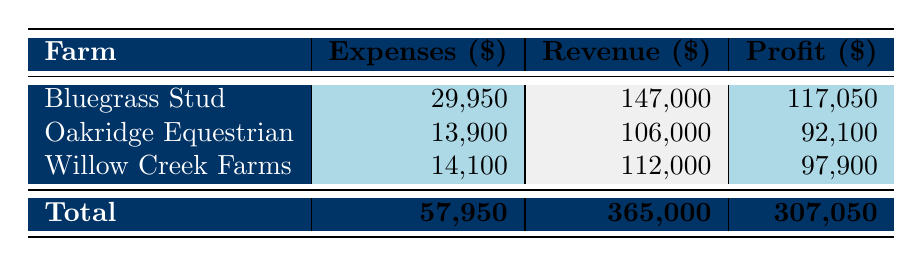What is the total profit for Bluegrass Stud? The profit for Bluegrass Stud can be found under the Profit column. It is stated as 117,050.
Answer: 117,050 How much did Willow Creek Farms spend on expenses? To find the total expenses for Willow Creek Farms, we refer to the Expenses column, which shows 14,100.
Answer: 14,100 Which farm has the highest revenue? The revenue amounts are 147,000 for Bluegrass Stud, 106,000 for Oakridge Equestrian, and 112,000 for Willow Creek Farms. Comparing these, Bluegrass Stud has the highest revenue.
Answer: Bluegrass Stud What is the total revenue across all farms? To find the total revenue, we sum the revenue for all farms: 147,000 + 106,000 + 112,000 = 365,000.
Answer: 365,000 Is the profit for Oakridge Equestrian greater than 80,000? The profit for Oakridge Equestrian is 92,100, which is more than 80,000.
Answer: Yes What is the average expense of the three farms? To calculate the average expenses, we first sum the total expenses: 29,950 + 13,900 + 14,100 = 57,950. Then we divide this by the number of farms, which is 3. Thus, the average is 57,950 / 3 = 19,316.67.
Answer: 19,316.67 Which farm has the lowest profit? The profits are 117,050 for Bluegrass Stud, 92,100 for Oakridge Equestrian, and 97,900 for Willow Creek Farms. Comparing these, Oakridge Equestrian has the lowest profit.
Answer: Oakridge Equestrian What is the difference in profit between Bluegrass Stud and Willow Creek Farms? The profit for Bluegrass Stud is 117,050, and for Willow Creek Farms, it is 97,900. The difference is 117,050 - 97,900 = 19,150.
Answer: 19,150 Does any farm have expenses greater than 30,000? The expenses for Bluegrass Stud are 29,950, for Oakridge Equestrian are 13,900, and for Willow Creek Farms are 14,100. None of these exceed 30,000.
Answer: No 